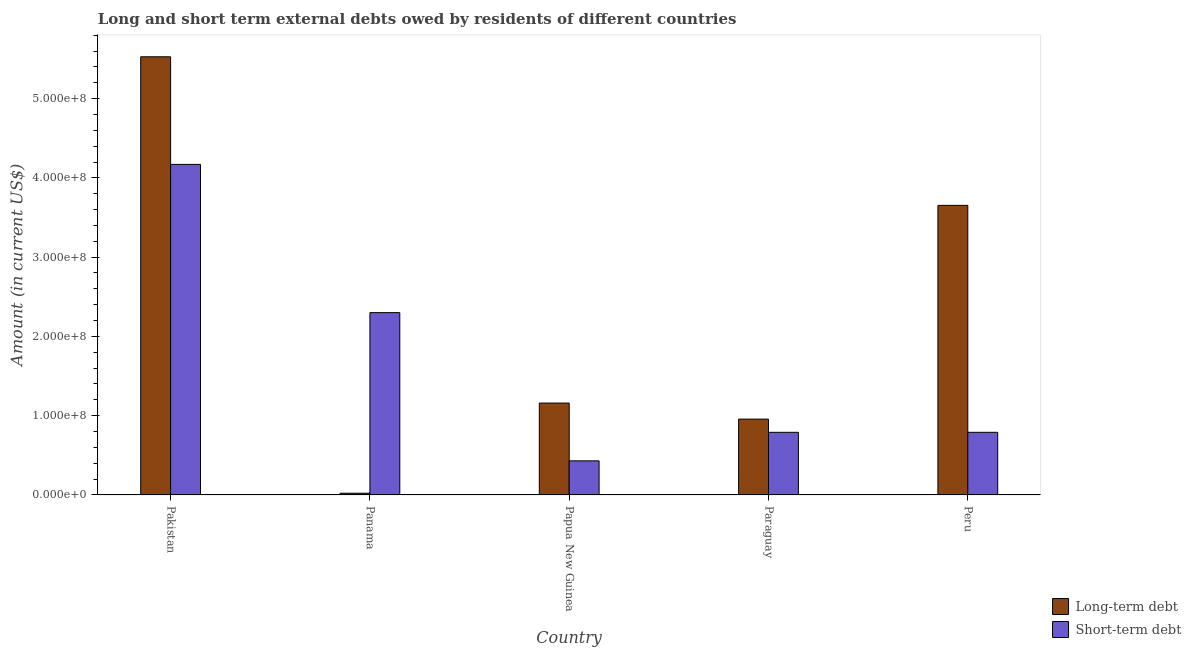How many groups of bars are there?
Offer a very short reply. 5. Are the number of bars on each tick of the X-axis equal?
Keep it short and to the point. Yes. How many bars are there on the 3rd tick from the left?
Provide a short and direct response. 2. What is the label of the 5th group of bars from the left?
Offer a very short reply. Peru. What is the long-term debts owed by residents in Papua New Guinea?
Provide a short and direct response. 1.16e+08. Across all countries, what is the maximum short-term debts owed by residents?
Keep it short and to the point. 4.17e+08. Across all countries, what is the minimum short-term debts owed by residents?
Offer a terse response. 4.30e+07. In which country was the long-term debts owed by residents minimum?
Your answer should be very brief. Panama. What is the total short-term debts owed by residents in the graph?
Offer a terse response. 8.48e+08. What is the difference between the short-term debts owed by residents in Pakistan and that in Panama?
Provide a succinct answer. 1.87e+08. What is the difference between the short-term debts owed by residents in Paraguay and the long-term debts owed by residents in Papua New Guinea?
Provide a short and direct response. -3.69e+07. What is the average long-term debts owed by residents per country?
Keep it short and to the point. 2.26e+08. What is the difference between the long-term debts owed by residents and short-term debts owed by residents in Paraguay?
Provide a short and direct response. 1.67e+07. What is the ratio of the long-term debts owed by residents in Pakistan to that in Panama?
Provide a succinct answer. 257.71. Is the difference between the long-term debts owed by residents in Pakistan and Paraguay greater than the difference between the short-term debts owed by residents in Pakistan and Paraguay?
Offer a very short reply. Yes. What is the difference between the highest and the second highest short-term debts owed by residents?
Offer a terse response. 1.87e+08. What is the difference between the highest and the lowest long-term debts owed by residents?
Offer a terse response. 5.51e+08. In how many countries, is the long-term debts owed by residents greater than the average long-term debts owed by residents taken over all countries?
Make the answer very short. 2. Is the sum of the short-term debts owed by residents in Panama and Papua New Guinea greater than the maximum long-term debts owed by residents across all countries?
Give a very brief answer. No. What does the 1st bar from the left in Paraguay represents?
Provide a short and direct response. Long-term debt. What does the 1st bar from the right in Papua New Guinea represents?
Make the answer very short. Short-term debt. How many bars are there?
Ensure brevity in your answer.  10. Are all the bars in the graph horizontal?
Offer a terse response. No. How many countries are there in the graph?
Make the answer very short. 5. What is the difference between two consecutive major ticks on the Y-axis?
Your response must be concise. 1.00e+08. Does the graph contain any zero values?
Your answer should be very brief. No. How are the legend labels stacked?
Provide a short and direct response. Vertical. What is the title of the graph?
Provide a succinct answer. Long and short term external debts owed by residents of different countries. Does "Formally registered" appear as one of the legend labels in the graph?
Give a very brief answer. No. What is the label or title of the X-axis?
Provide a succinct answer. Country. What is the label or title of the Y-axis?
Make the answer very short. Amount (in current US$). What is the Amount (in current US$) of Long-term debt in Pakistan?
Ensure brevity in your answer.  5.53e+08. What is the Amount (in current US$) in Short-term debt in Pakistan?
Your answer should be compact. 4.17e+08. What is the Amount (in current US$) in Long-term debt in Panama?
Give a very brief answer. 2.14e+06. What is the Amount (in current US$) in Short-term debt in Panama?
Offer a very short reply. 2.30e+08. What is the Amount (in current US$) of Long-term debt in Papua New Guinea?
Provide a short and direct response. 1.16e+08. What is the Amount (in current US$) in Short-term debt in Papua New Guinea?
Offer a very short reply. 4.30e+07. What is the Amount (in current US$) in Long-term debt in Paraguay?
Provide a short and direct response. 9.57e+07. What is the Amount (in current US$) in Short-term debt in Paraguay?
Offer a very short reply. 7.90e+07. What is the Amount (in current US$) in Long-term debt in Peru?
Provide a short and direct response. 3.65e+08. What is the Amount (in current US$) of Short-term debt in Peru?
Your response must be concise. 7.90e+07. Across all countries, what is the maximum Amount (in current US$) in Long-term debt?
Offer a very short reply. 5.53e+08. Across all countries, what is the maximum Amount (in current US$) in Short-term debt?
Provide a short and direct response. 4.17e+08. Across all countries, what is the minimum Amount (in current US$) in Long-term debt?
Give a very brief answer. 2.14e+06. Across all countries, what is the minimum Amount (in current US$) in Short-term debt?
Offer a terse response. 4.30e+07. What is the total Amount (in current US$) of Long-term debt in the graph?
Your answer should be very brief. 1.13e+09. What is the total Amount (in current US$) in Short-term debt in the graph?
Your response must be concise. 8.48e+08. What is the difference between the Amount (in current US$) of Long-term debt in Pakistan and that in Panama?
Your response must be concise. 5.51e+08. What is the difference between the Amount (in current US$) of Short-term debt in Pakistan and that in Panama?
Your answer should be very brief. 1.87e+08. What is the difference between the Amount (in current US$) in Long-term debt in Pakistan and that in Papua New Guinea?
Give a very brief answer. 4.37e+08. What is the difference between the Amount (in current US$) of Short-term debt in Pakistan and that in Papua New Guinea?
Your answer should be compact. 3.74e+08. What is the difference between the Amount (in current US$) in Long-term debt in Pakistan and that in Paraguay?
Give a very brief answer. 4.57e+08. What is the difference between the Amount (in current US$) of Short-term debt in Pakistan and that in Paraguay?
Provide a succinct answer. 3.38e+08. What is the difference between the Amount (in current US$) in Long-term debt in Pakistan and that in Peru?
Provide a short and direct response. 1.87e+08. What is the difference between the Amount (in current US$) in Short-term debt in Pakistan and that in Peru?
Ensure brevity in your answer.  3.38e+08. What is the difference between the Amount (in current US$) of Long-term debt in Panama and that in Papua New Guinea?
Your response must be concise. -1.14e+08. What is the difference between the Amount (in current US$) in Short-term debt in Panama and that in Papua New Guinea?
Ensure brevity in your answer.  1.87e+08. What is the difference between the Amount (in current US$) of Long-term debt in Panama and that in Paraguay?
Ensure brevity in your answer.  -9.35e+07. What is the difference between the Amount (in current US$) of Short-term debt in Panama and that in Paraguay?
Ensure brevity in your answer.  1.51e+08. What is the difference between the Amount (in current US$) in Long-term debt in Panama and that in Peru?
Your answer should be compact. -3.63e+08. What is the difference between the Amount (in current US$) in Short-term debt in Panama and that in Peru?
Give a very brief answer. 1.51e+08. What is the difference between the Amount (in current US$) in Long-term debt in Papua New Guinea and that in Paraguay?
Offer a terse response. 2.03e+07. What is the difference between the Amount (in current US$) of Short-term debt in Papua New Guinea and that in Paraguay?
Provide a short and direct response. -3.60e+07. What is the difference between the Amount (in current US$) of Long-term debt in Papua New Guinea and that in Peru?
Offer a very short reply. -2.49e+08. What is the difference between the Amount (in current US$) of Short-term debt in Papua New Guinea and that in Peru?
Offer a terse response. -3.60e+07. What is the difference between the Amount (in current US$) in Long-term debt in Paraguay and that in Peru?
Provide a succinct answer. -2.70e+08. What is the difference between the Amount (in current US$) of Short-term debt in Paraguay and that in Peru?
Give a very brief answer. 0. What is the difference between the Amount (in current US$) in Long-term debt in Pakistan and the Amount (in current US$) in Short-term debt in Panama?
Give a very brief answer. 3.23e+08. What is the difference between the Amount (in current US$) of Long-term debt in Pakistan and the Amount (in current US$) of Short-term debt in Papua New Guinea?
Ensure brevity in your answer.  5.10e+08. What is the difference between the Amount (in current US$) in Long-term debt in Pakistan and the Amount (in current US$) in Short-term debt in Paraguay?
Ensure brevity in your answer.  4.74e+08. What is the difference between the Amount (in current US$) of Long-term debt in Pakistan and the Amount (in current US$) of Short-term debt in Peru?
Your answer should be compact. 4.74e+08. What is the difference between the Amount (in current US$) in Long-term debt in Panama and the Amount (in current US$) in Short-term debt in Papua New Guinea?
Keep it short and to the point. -4.09e+07. What is the difference between the Amount (in current US$) of Long-term debt in Panama and the Amount (in current US$) of Short-term debt in Paraguay?
Keep it short and to the point. -7.69e+07. What is the difference between the Amount (in current US$) in Long-term debt in Panama and the Amount (in current US$) in Short-term debt in Peru?
Give a very brief answer. -7.69e+07. What is the difference between the Amount (in current US$) of Long-term debt in Papua New Guinea and the Amount (in current US$) of Short-term debt in Paraguay?
Offer a terse response. 3.69e+07. What is the difference between the Amount (in current US$) in Long-term debt in Papua New Guinea and the Amount (in current US$) in Short-term debt in Peru?
Provide a succinct answer. 3.69e+07. What is the difference between the Amount (in current US$) of Long-term debt in Paraguay and the Amount (in current US$) of Short-term debt in Peru?
Your response must be concise. 1.67e+07. What is the average Amount (in current US$) in Long-term debt per country?
Your response must be concise. 2.26e+08. What is the average Amount (in current US$) in Short-term debt per country?
Ensure brevity in your answer.  1.70e+08. What is the difference between the Amount (in current US$) in Long-term debt and Amount (in current US$) in Short-term debt in Pakistan?
Your answer should be very brief. 1.36e+08. What is the difference between the Amount (in current US$) of Long-term debt and Amount (in current US$) of Short-term debt in Panama?
Ensure brevity in your answer.  -2.28e+08. What is the difference between the Amount (in current US$) in Long-term debt and Amount (in current US$) in Short-term debt in Papua New Guinea?
Your response must be concise. 7.29e+07. What is the difference between the Amount (in current US$) in Long-term debt and Amount (in current US$) in Short-term debt in Paraguay?
Provide a succinct answer. 1.67e+07. What is the difference between the Amount (in current US$) of Long-term debt and Amount (in current US$) of Short-term debt in Peru?
Your answer should be very brief. 2.86e+08. What is the ratio of the Amount (in current US$) in Long-term debt in Pakistan to that in Panama?
Offer a terse response. 257.71. What is the ratio of the Amount (in current US$) of Short-term debt in Pakistan to that in Panama?
Make the answer very short. 1.81. What is the ratio of the Amount (in current US$) in Long-term debt in Pakistan to that in Papua New Guinea?
Your answer should be compact. 4.77. What is the ratio of the Amount (in current US$) of Short-term debt in Pakistan to that in Papua New Guinea?
Offer a very short reply. 9.7. What is the ratio of the Amount (in current US$) of Long-term debt in Pakistan to that in Paraguay?
Keep it short and to the point. 5.78. What is the ratio of the Amount (in current US$) in Short-term debt in Pakistan to that in Paraguay?
Ensure brevity in your answer.  5.28. What is the ratio of the Amount (in current US$) in Long-term debt in Pakistan to that in Peru?
Your answer should be very brief. 1.51. What is the ratio of the Amount (in current US$) in Short-term debt in Pakistan to that in Peru?
Your response must be concise. 5.28. What is the ratio of the Amount (in current US$) of Long-term debt in Panama to that in Papua New Guinea?
Give a very brief answer. 0.02. What is the ratio of the Amount (in current US$) of Short-term debt in Panama to that in Papua New Guinea?
Ensure brevity in your answer.  5.35. What is the ratio of the Amount (in current US$) in Long-term debt in Panama to that in Paraguay?
Offer a terse response. 0.02. What is the ratio of the Amount (in current US$) of Short-term debt in Panama to that in Paraguay?
Keep it short and to the point. 2.91. What is the ratio of the Amount (in current US$) of Long-term debt in Panama to that in Peru?
Your answer should be compact. 0.01. What is the ratio of the Amount (in current US$) in Short-term debt in Panama to that in Peru?
Your response must be concise. 2.91. What is the ratio of the Amount (in current US$) of Long-term debt in Papua New Guinea to that in Paraguay?
Provide a succinct answer. 1.21. What is the ratio of the Amount (in current US$) of Short-term debt in Papua New Guinea to that in Paraguay?
Your answer should be very brief. 0.54. What is the ratio of the Amount (in current US$) in Long-term debt in Papua New Guinea to that in Peru?
Ensure brevity in your answer.  0.32. What is the ratio of the Amount (in current US$) in Short-term debt in Papua New Guinea to that in Peru?
Provide a succinct answer. 0.54. What is the ratio of the Amount (in current US$) in Long-term debt in Paraguay to that in Peru?
Ensure brevity in your answer.  0.26. What is the difference between the highest and the second highest Amount (in current US$) of Long-term debt?
Keep it short and to the point. 1.87e+08. What is the difference between the highest and the second highest Amount (in current US$) in Short-term debt?
Your response must be concise. 1.87e+08. What is the difference between the highest and the lowest Amount (in current US$) in Long-term debt?
Provide a succinct answer. 5.51e+08. What is the difference between the highest and the lowest Amount (in current US$) of Short-term debt?
Give a very brief answer. 3.74e+08. 